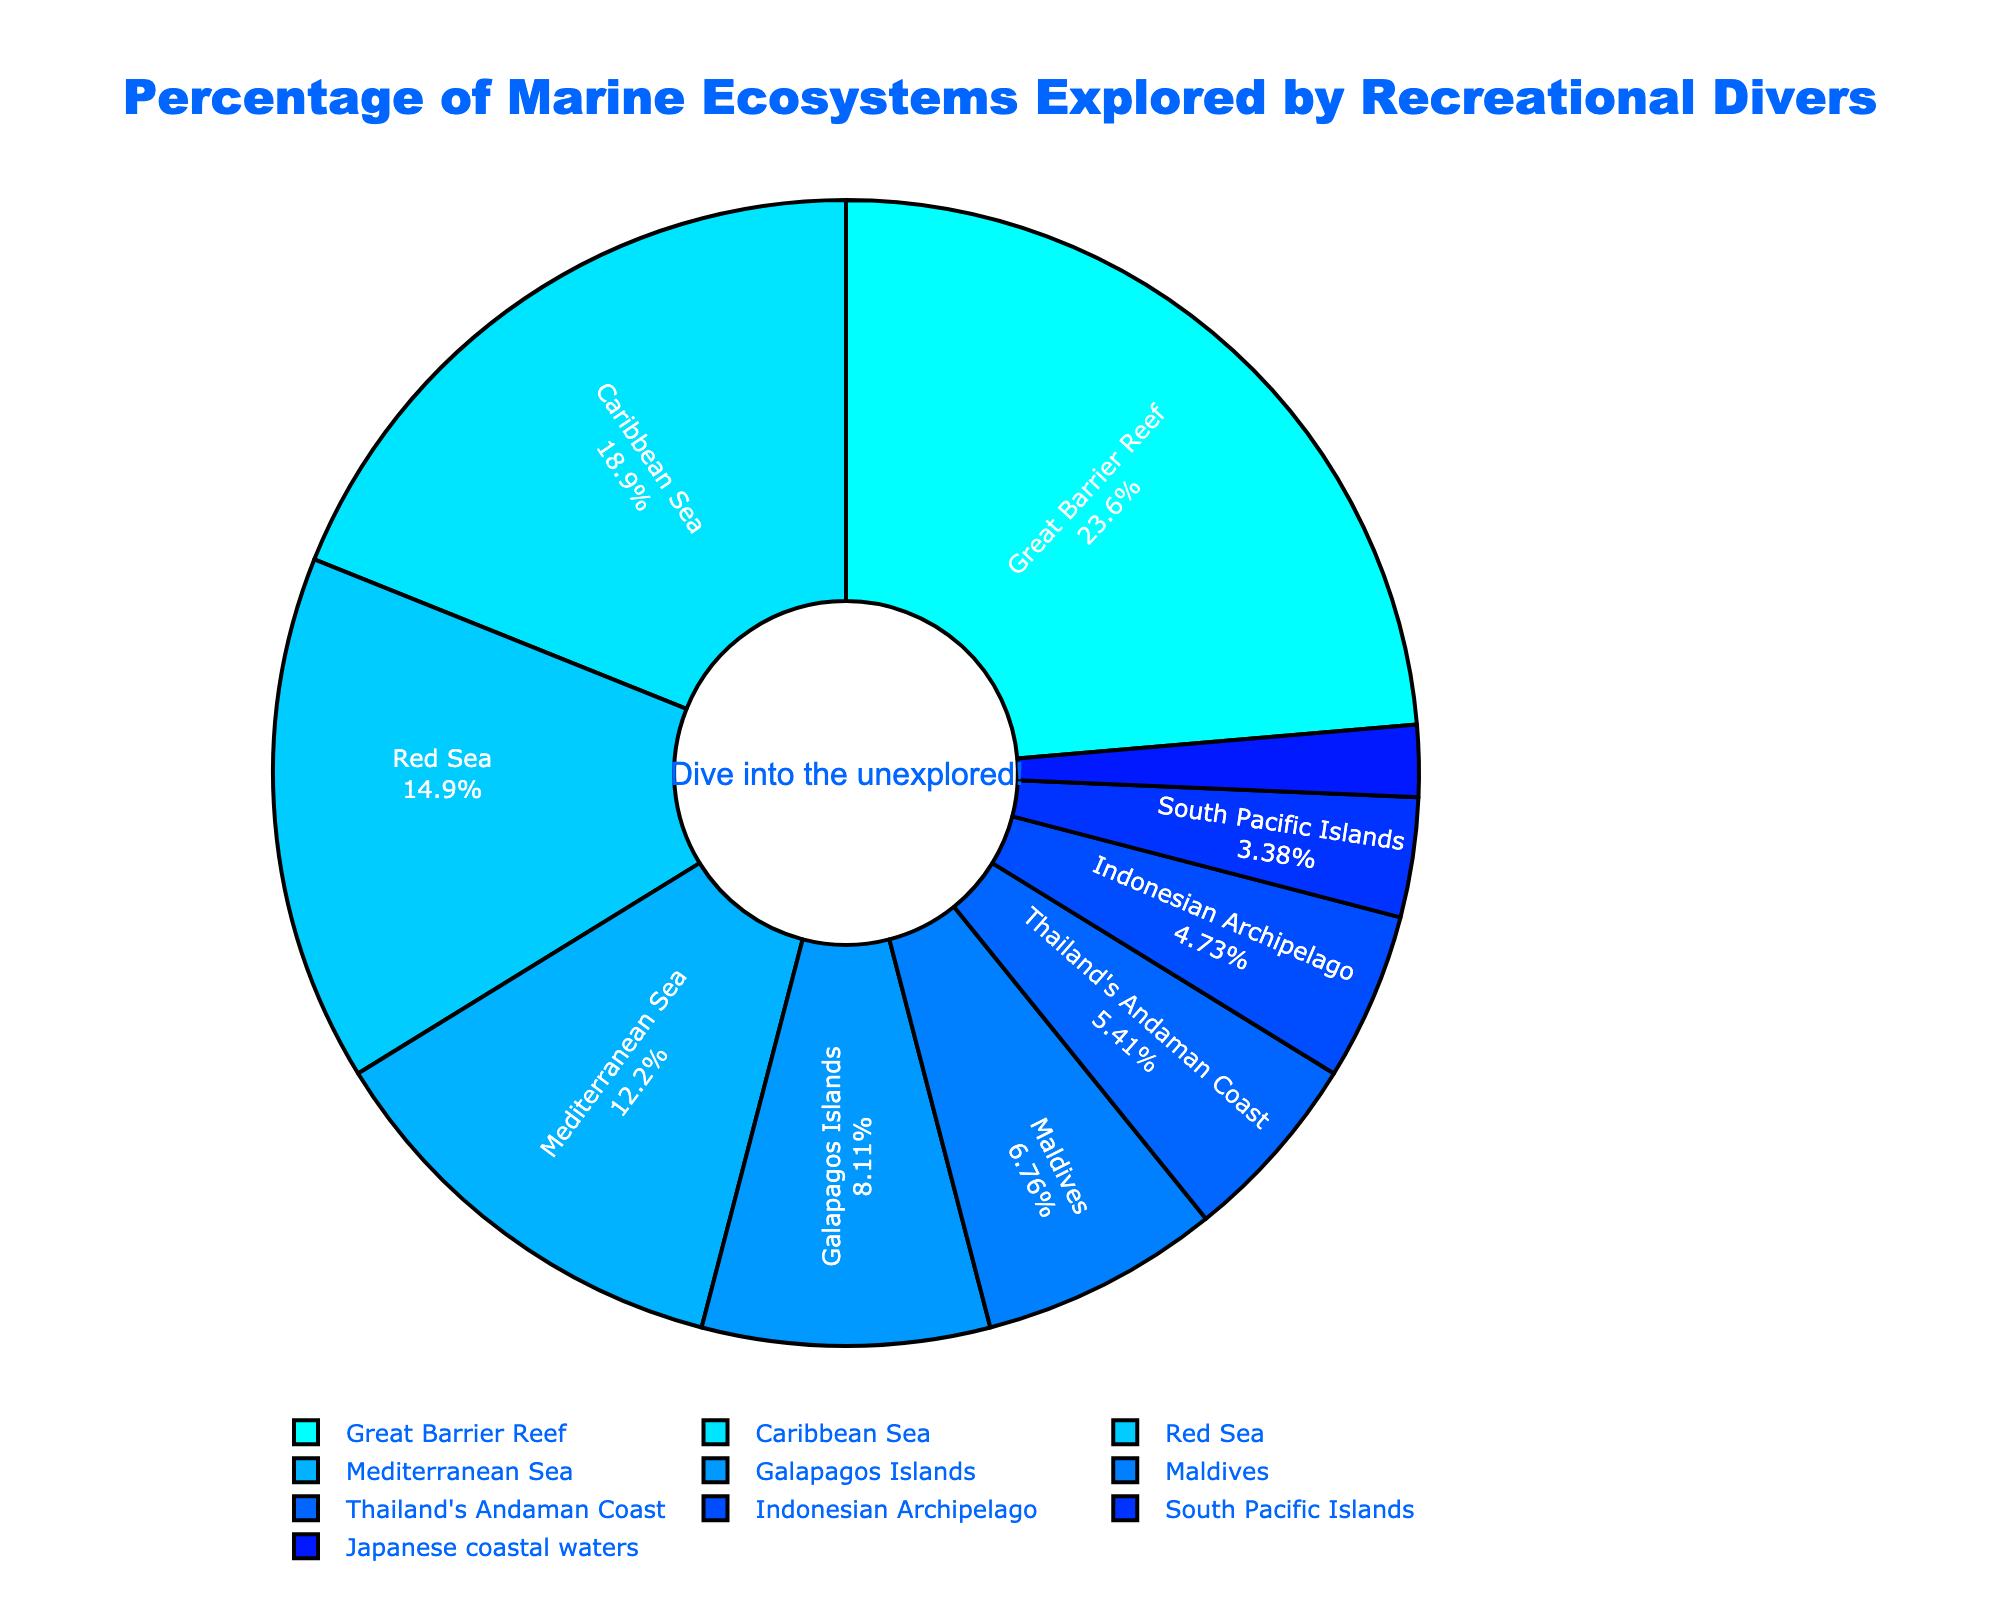What ecosystem has the largest percentage of recreational divers? The Great Barrier Reef has the largest segment in the pie chart, showing a percentage of 35%.
Answer: The Great Barrier Reef What is the combined percentage of divers exploring the Galapagos Islands, Maldives, and the Indonesian Archipelago? Add the percentages of the Galapagos Islands (12%), Maldives (10%), and Indonesian Archipelago (7%): 12% + 10% + 7% = 29%.
Answer: 29% Which ecosystem has more recreational divers: Caribbean Sea or Red Sea? The Caribbean Sea has a segment with 28%, whereas the Red Sea has a segment with 22%. Therefore, the Caribbean Sea has a higher percentage.
Answer: Caribbean Sea Are the percentages of recreational divers in Thailand's Andaman Coast and Japanese coastal waters equal? The segment for Thailand's Andaman Coast is 8% and the segment for Japanese coastal waters is 3%. They are not equal.
Answer: No What is the difference in the percentage of divers between the Great Barrier Reef and the South Pacific Islands? Subtract the percentage of the South Pacific Islands (5%) from the percentage of the Great Barrier Reef (35%): 35% - 5% = 30%.
Answer: 30% Which ecosystem has the smallest percentage of divers? The smallest segment in the pie chart represents the Japanese coastal waters with 3%.
Answer: Japanese coastal waters How does the percentage of divers in the Mediterranean Sea compare to that in the Maldives? The Mediterranean Sea has a percentage of 18%, while the Maldives has 10%. Therefore, the percentage in the Mediterranean Sea is higher.
Answer: Mediterranean Sea Calculate the average percentage of divers for the Great Barrier Reef, Caribbean Sea, and Red Sea. Add the percentages for the Great Barrier Reef (35%), Caribbean Sea (28%), and Red Sea (22%), then divide by the number of ecosystems (3): (35% + 28% + 22%) / 3 = 85% / 3 ≈ 28.33%.
Answer: 28.33% What is the total percentage of recreational divers in the Mediterranean Sea, Maldives, and Japan? Add the percentages of the Mediterranean Sea (18%), Maldives (10%), and Japanese coastal waters (3%): 18% + 10% + 3% = 31%.
Answer: 31% Is the percentage of divers in the Indonesian Archipelago greater than that in Thailand's Andaman Coast? The Indonesian Archipelago has a segment of 7%, while Thailand's Andaman Coast has a segment of 8%. So, the Indonesian Archipelago has a smaller percentage.
Answer: No 